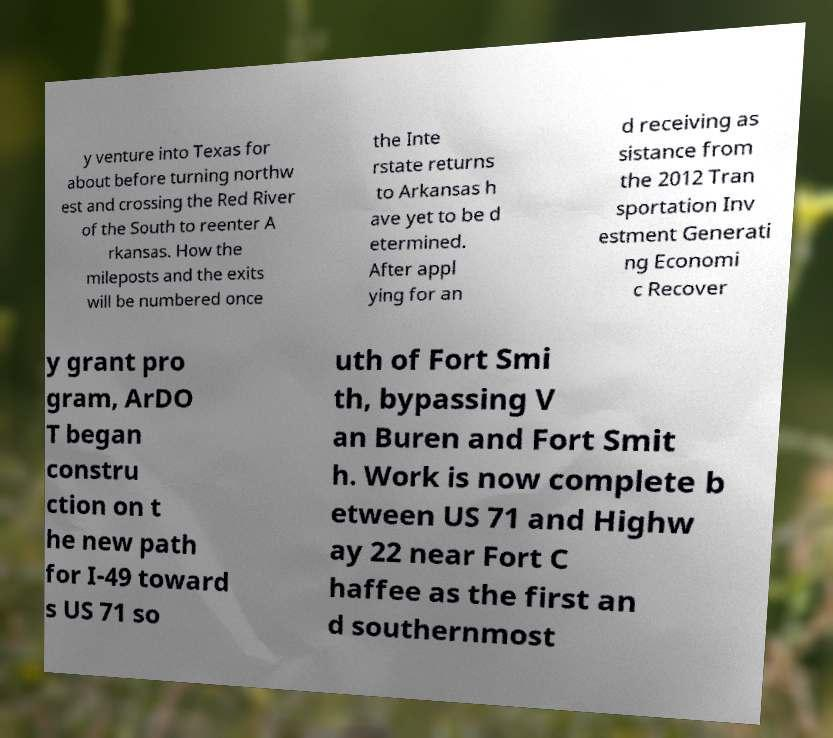What messages or text are displayed in this image? I need them in a readable, typed format. y venture into Texas for about before turning northw est and crossing the Red River of the South to reenter A rkansas. How the mileposts and the exits will be numbered once the Inte rstate returns to Arkansas h ave yet to be d etermined. After appl ying for an d receiving as sistance from the 2012 Tran sportation Inv estment Generati ng Economi c Recover y grant pro gram, ArDO T began constru ction on t he new path for I-49 toward s US 71 so uth of Fort Smi th, bypassing V an Buren and Fort Smit h. Work is now complete b etween US 71 and Highw ay 22 near Fort C haffee as the first an d southernmost 